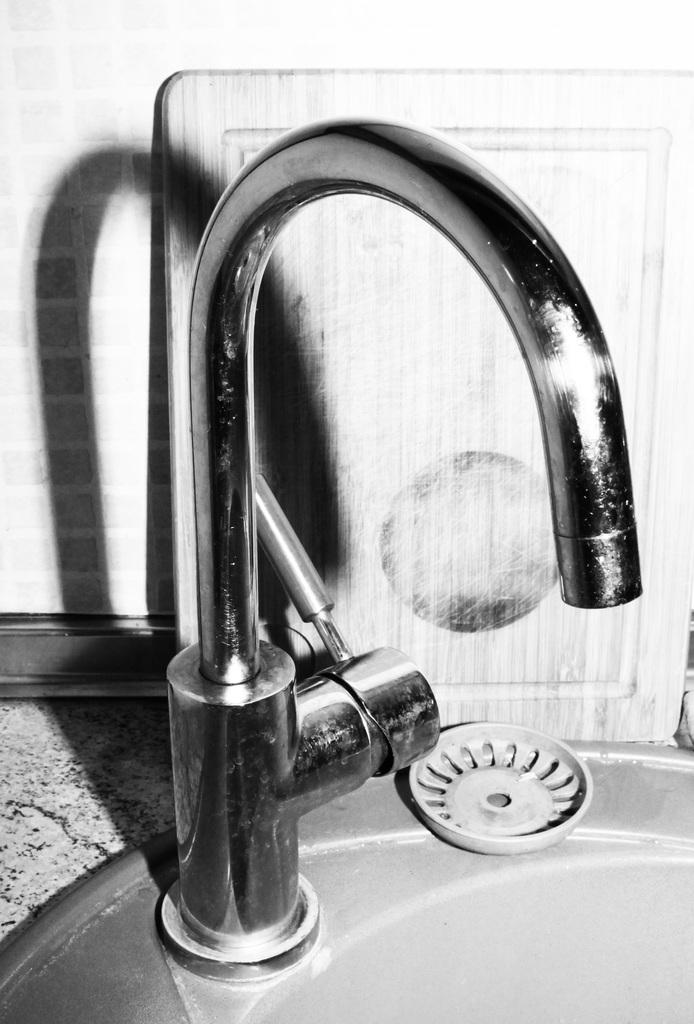What is the main object in the center of the image? There is a tap in the center of the image. What type of peace treaty is being signed by the two figures in the image? There are no figures or peace treaty present in the image; it only features a tap. 